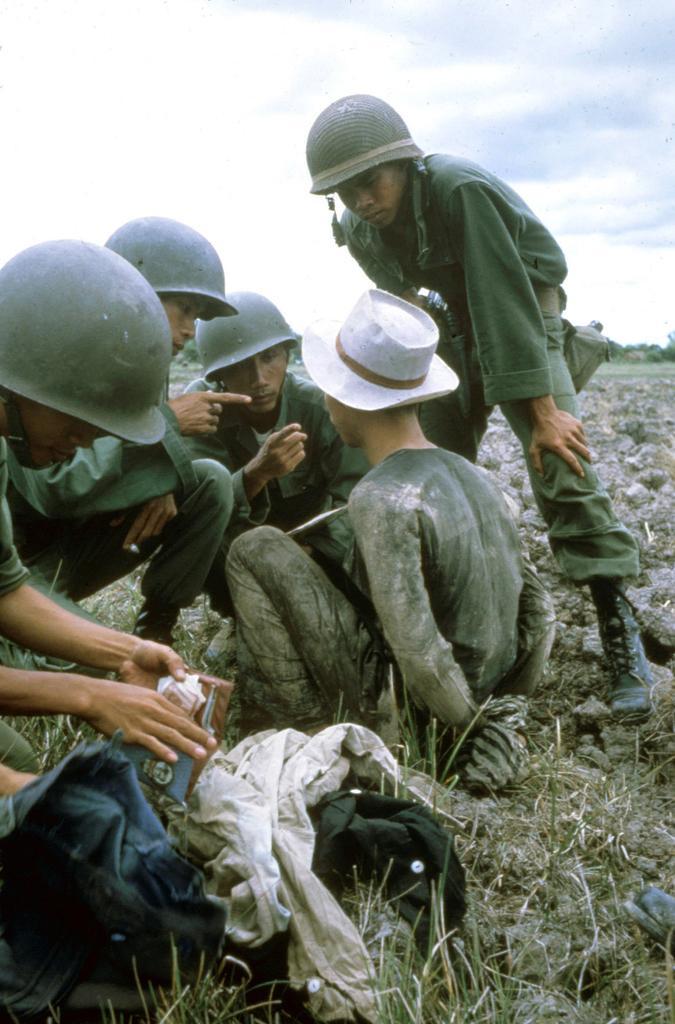Describe this image in one or two sentences. In the image in the center we can see four persons were sitting and one person standing. And they were wearing helmet. In front of the image,we can see bag,cloth,wallet and grass. In the background we can see sky,clouds,trees,grass and stones. 